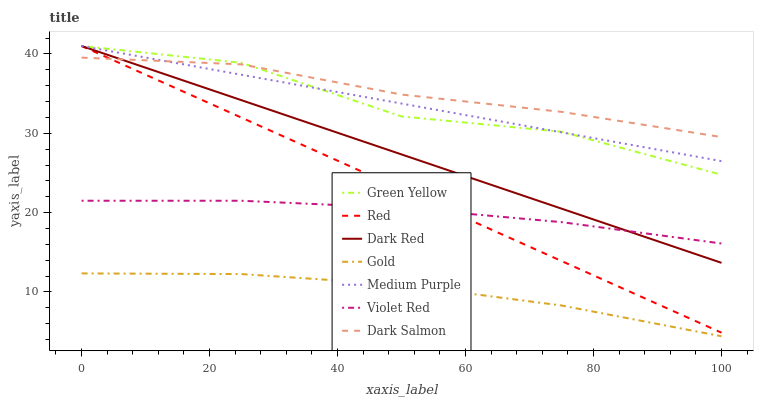Does Gold have the minimum area under the curve?
Answer yes or no. Yes. Does Dark Salmon have the maximum area under the curve?
Answer yes or no. Yes. Does Dark Red have the minimum area under the curve?
Answer yes or no. No. Does Dark Red have the maximum area under the curve?
Answer yes or no. No. Is Dark Red the smoothest?
Answer yes or no. Yes. Is Green Yellow the roughest?
Answer yes or no. Yes. Is Gold the smoothest?
Answer yes or no. No. Is Gold the roughest?
Answer yes or no. No. Does Gold have the lowest value?
Answer yes or no. Yes. Does Dark Red have the lowest value?
Answer yes or no. No. Does Red have the highest value?
Answer yes or no. Yes. Does Gold have the highest value?
Answer yes or no. No. Is Gold less than Violet Red?
Answer yes or no. Yes. Is Dark Salmon greater than Gold?
Answer yes or no. Yes. Does Green Yellow intersect Medium Purple?
Answer yes or no. Yes. Is Green Yellow less than Medium Purple?
Answer yes or no. No. Is Green Yellow greater than Medium Purple?
Answer yes or no. No. Does Gold intersect Violet Red?
Answer yes or no. No. 